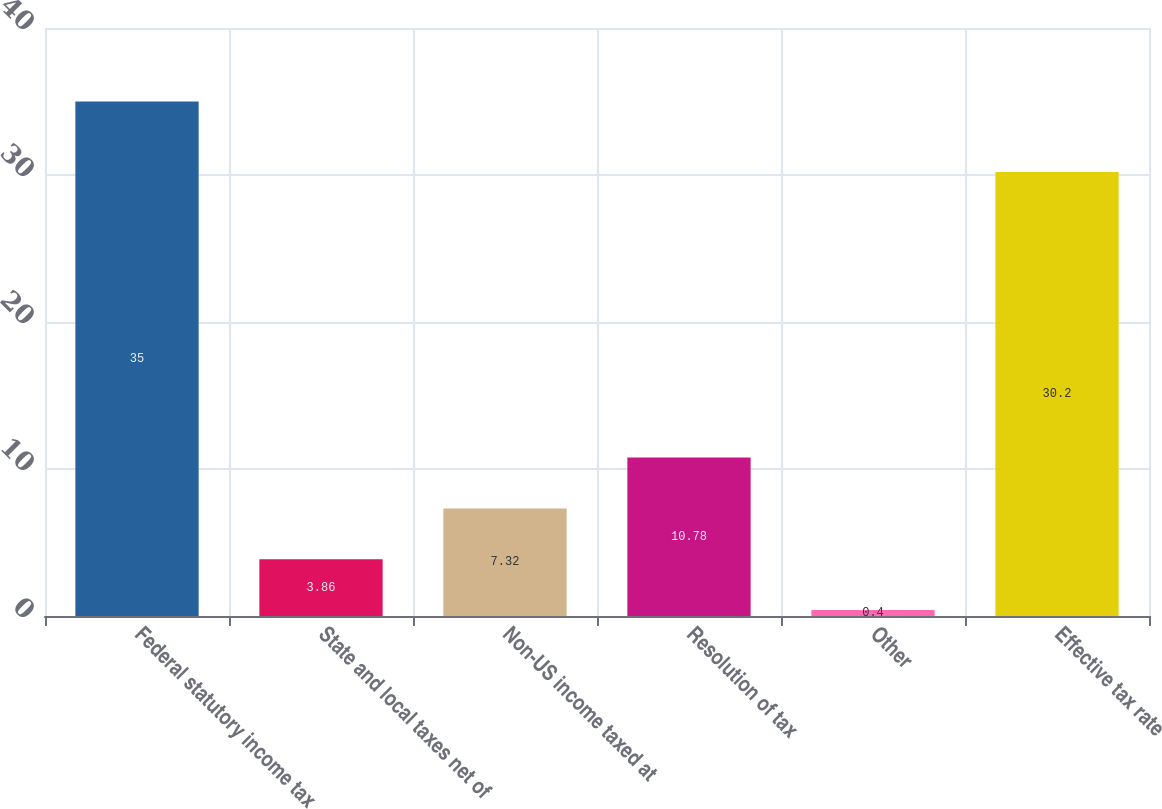Convert chart to OTSL. <chart><loc_0><loc_0><loc_500><loc_500><bar_chart><fcel>Federal statutory income tax<fcel>State and local taxes net of<fcel>Non-US income taxed at<fcel>Resolution of tax<fcel>Other<fcel>Effective tax rate<nl><fcel>35<fcel>3.86<fcel>7.32<fcel>10.78<fcel>0.4<fcel>30.2<nl></chart> 